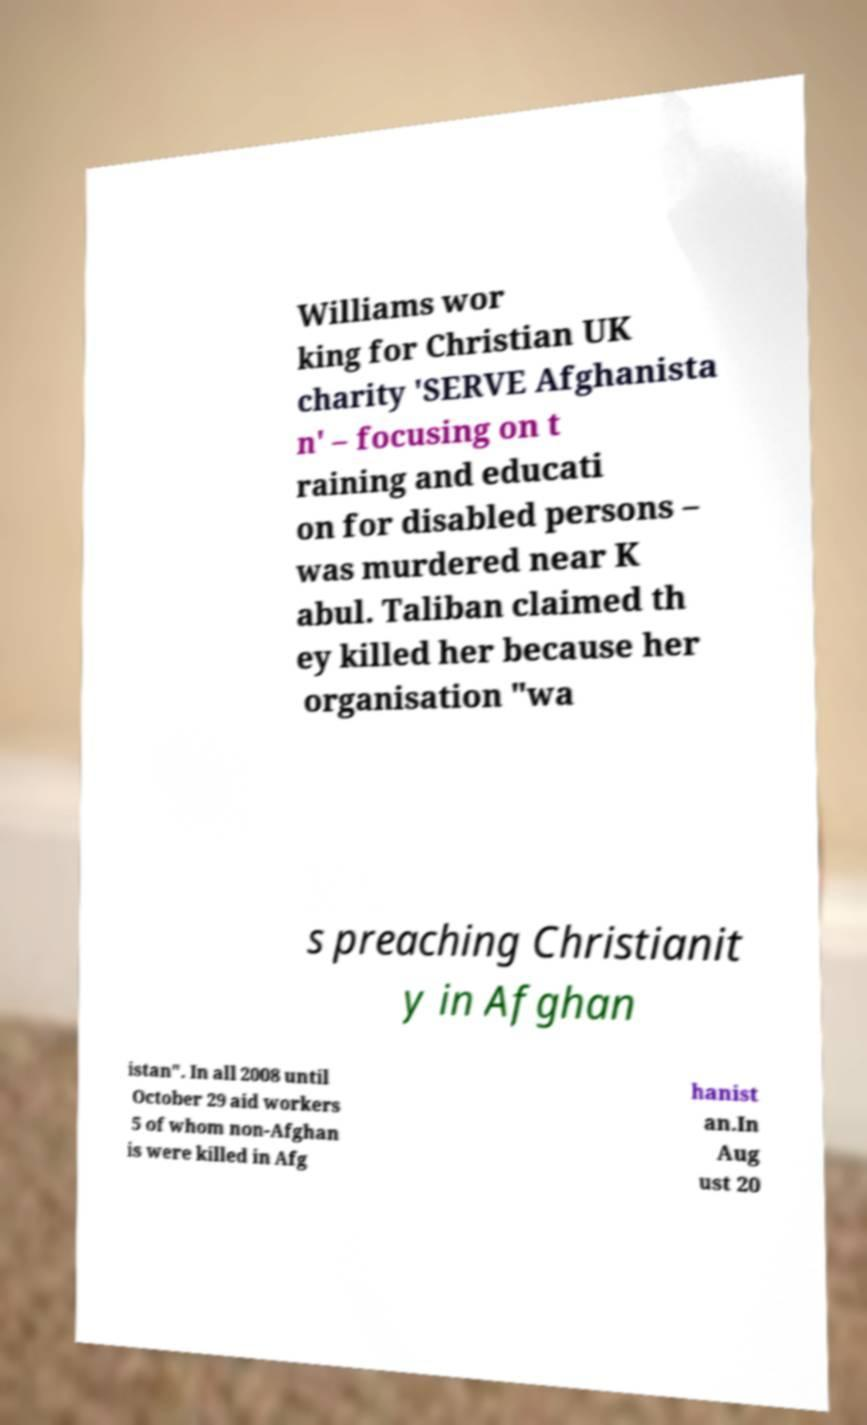Can you read and provide the text displayed in the image?This photo seems to have some interesting text. Can you extract and type it out for me? Williams wor king for Christian UK charity 'SERVE Afghanista n' – focusing on t raining and educati on for disabled persons – was murdered near K abul. Taliban claimed th ey killed her because her organisation "wa s preaching Christianit y in Afghan istan". In all 2008 until October 29 aid workers 5 of whom non-Afghan is were killed in Afg hanist an.In Aug ust 20 